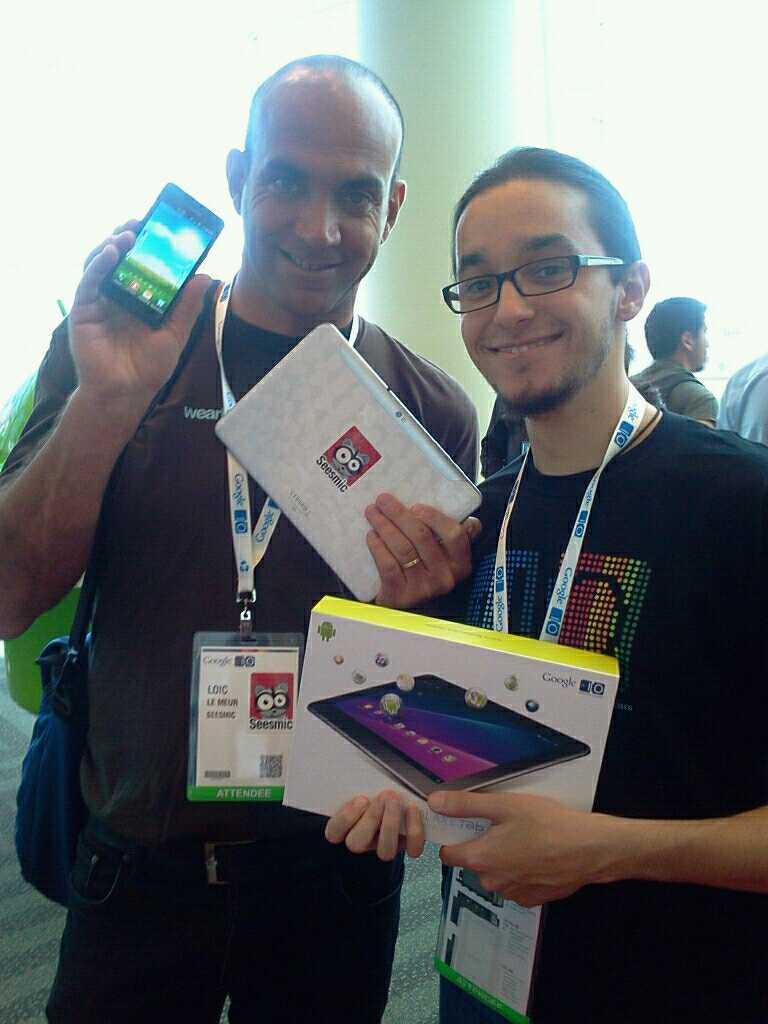How many people are in the center of the image? There are two persons in the center of the image. What can be seen on the persons' clothing? The persons are wearing ID cards. What are the persons holding in their hands? The persons are holding objects in their hands. What can be seen in the background of the image? There is a pillar and people in the background of the image. What type of food is being served on the island in the image? There is no island or food present in the image; it features two persons in the center holding objects and a background with a pillar and people. 